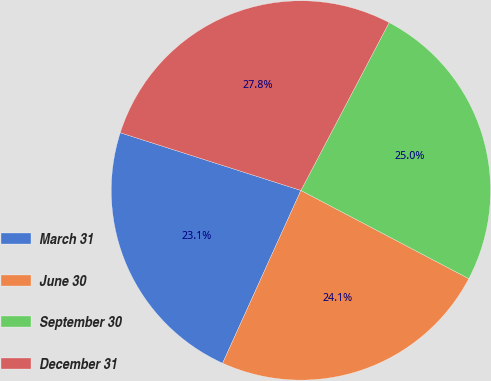Convert chart. <chart><loc_0><loc_0><loc_500><loc_500><pie_chart><fcel>March 31<fcel>June 30<fcel>September 30<fcel>December 31<nl><fcel>23.15%<fcel>24.07%<fcel>25.0%<fcel>27.78%<nl></chart> 